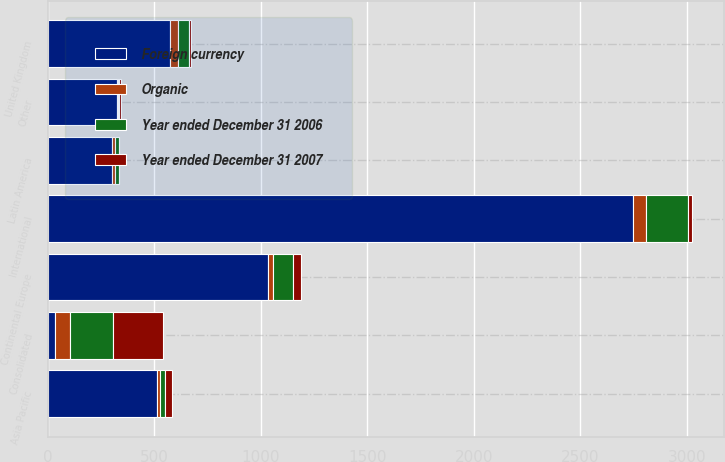<chart> <loc_0><loc_0><loc_500><loc_500><stacked_bar_chart><ecel><fcel>Consolidated<fcel>International<fcel>United Kingdom<fcel>Continental Europe<fcel>Asia Pacific<fcel>Latin America<fcel>Other<nl><fcel>Foreign currency<fcel>35.5<fcel>2747.4<fcel>574.5<fcel>1034.1<fcel>512<fcel>303.4<fcel>323.4<nl><fcel>Year ended December 31 2006<fcel>197.5<fcel>197.5<fcel>51.1<fcel>94.4<fcel>25.7<fcel>18.4<fcel>7.9<nl><fcel>Organic<fcel>70.7<fcel>61.4<fcel>35.5<fcel>24<fcel>12.5<fcel>10.6<fcel>3.8<nl><fcel>Year ended December 31 2007<fcel>236.6<fcel>19.4<fcel>13.5<fcel>34.3<fcel>31.1<fcel>2.9<fcel>6.2<nl></chart> 